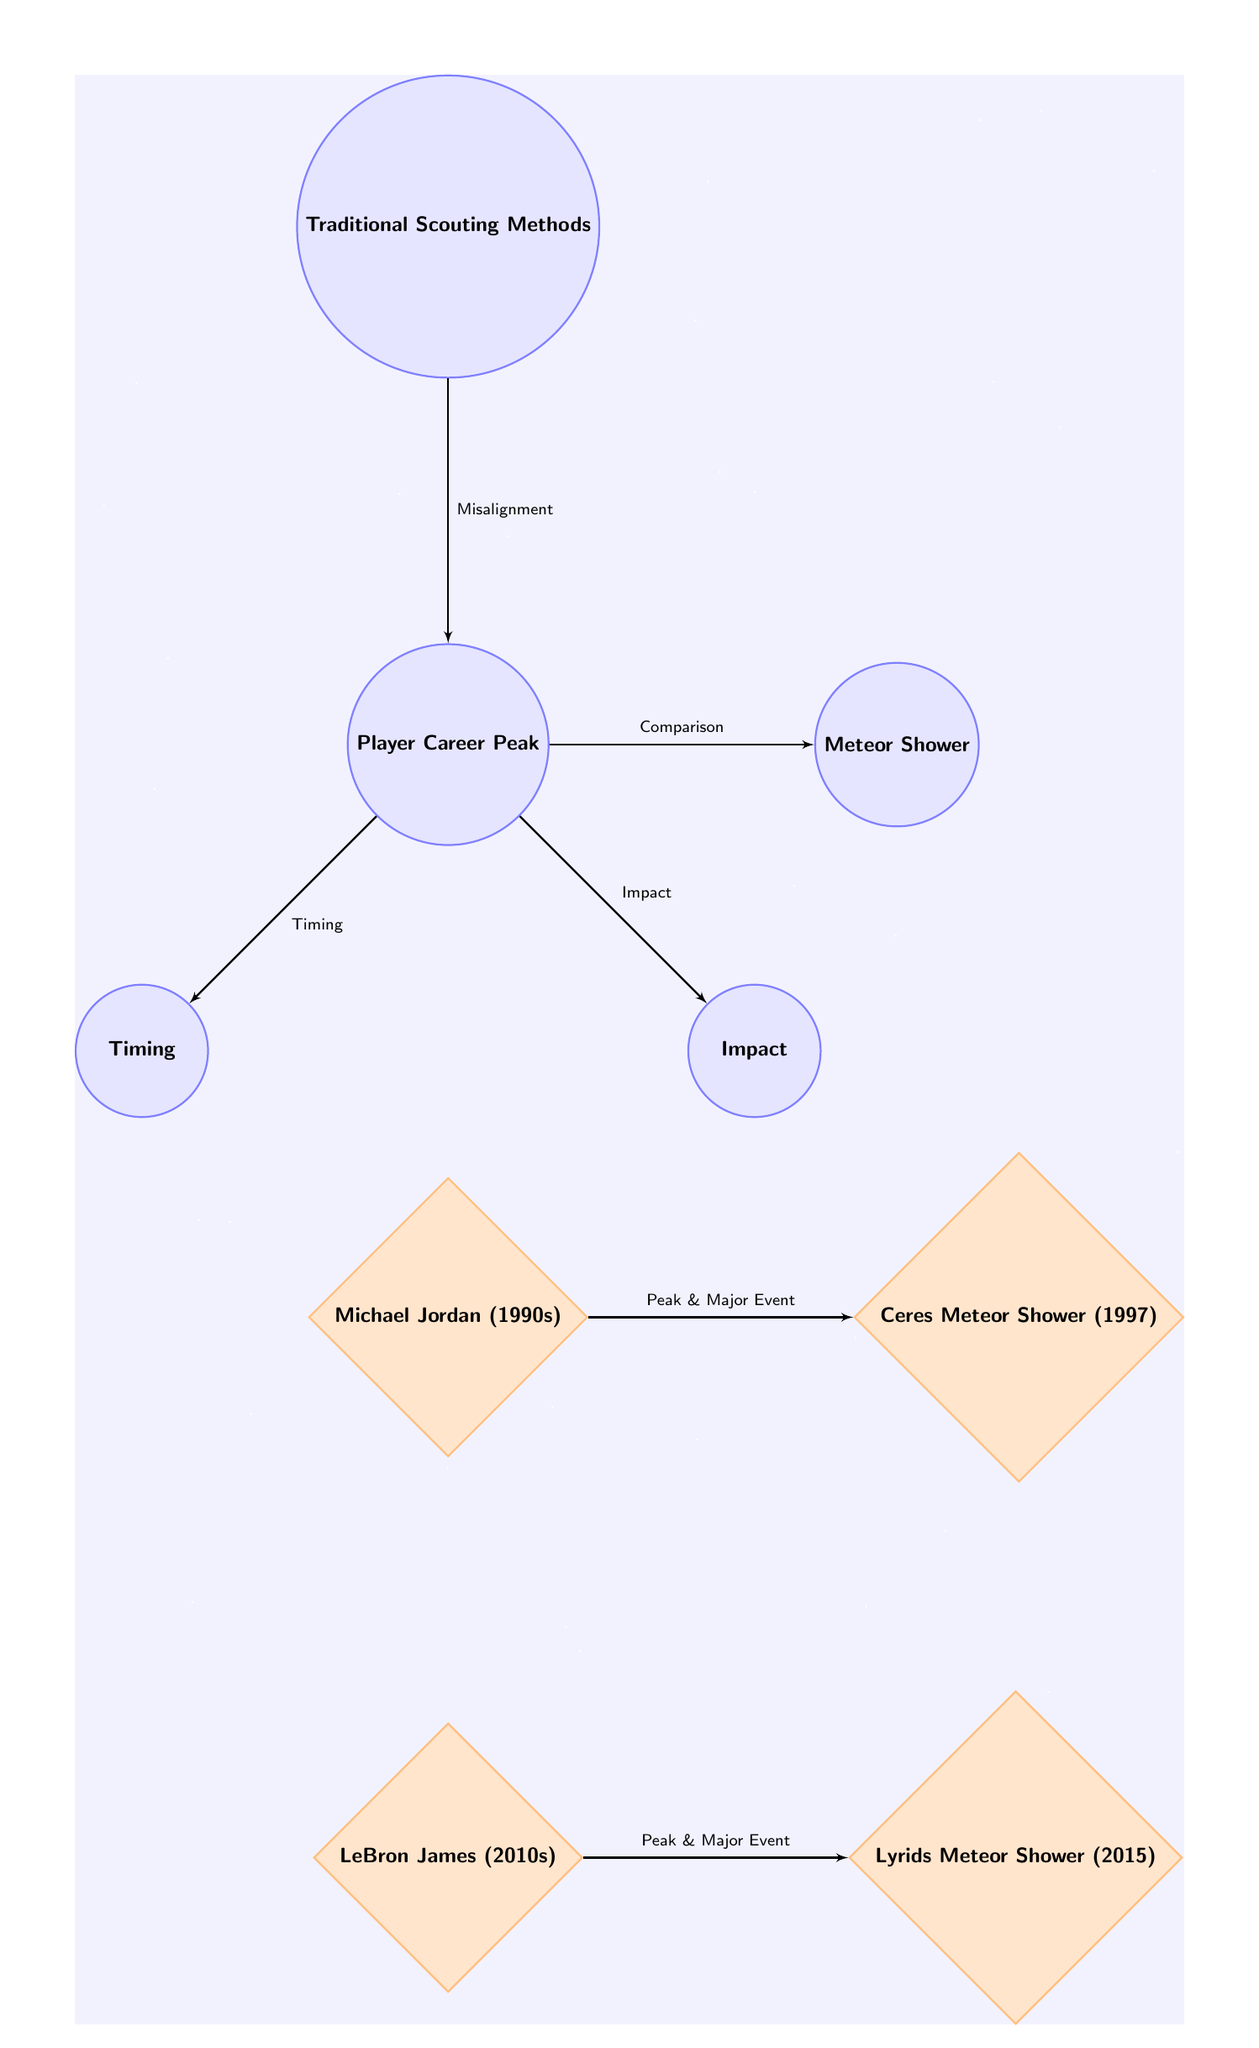What are the nodes in the diagram? The diagram contains five concept nodes: Player Career Peak, Meteor Shower, Timing, Impact, and Traditional Scouting Methods. Additionally, it contains two event nodes: Michael Jordan (1990s) and LeBron James (2010s), along with their related meteor showers.
Answer: Player Career Peak, Meteor Shower, Timing, Impact, Traditional Scouting Methods, Michael Jordan (1990s), LeBron James (2010s), Ceres Meteor Shower (1997), Lyrids Meteor Shower (2015) How many edges are present in the diagram? By counting all the connections drawn between the nodes, there are a total of six edges in the diagram.
Answer: 6 What is the connection between Michael Jordan and Ceres Meteor Shower? The connection is labeled "Peak & Major Event," indicating a significant relationship between Michael Jordan's peak career performance in the 1990s and the occurrence of the Ceres Meteor Shower in 1997.
Answer: Peak & Major Event Which meteor shower is associated with LeBron James? The diagram links LeBron James to the Lyrids Meteor Shower (2015) through the connection labeled "Peak & Major Event," showing their relationship during a career peak.
Answer: Lyrids Meteor Shower (2015) What does the edge labeled “Misalignment” signify? The edge labeled “Misalignment” signifies a relationship where Traditional Scouting Methods do not align well with identifying the timing or impact of Player Career Peaks, suggesting flaws in those methods.
Answer: Misalignment Which two significant concept nodes are connected through "Impact"? The nodes connected through "Impact" are Player Career Peak and Impact, representing the influence and results of a player's career peak.
Answer: Player Career Peak and Impact What does the diagram suggest about the timing of player peaks in relation to meteor showers? The diagram suggests that both Michael Jordan's and LeBron James's career peaks coincide with major meteor shower events, illustrating a correlation in timing between sports peaks and astronomical phenomena.
Answer: Correlation in timing Which node is positioned above Player Career Peak in the diagram? The node positioned above Player Career Peak is Traditional Scouting Methods. This placement may imply a conceptual hierarchy or focus in the analysis.
Answer: Traditional Scouting Methods 